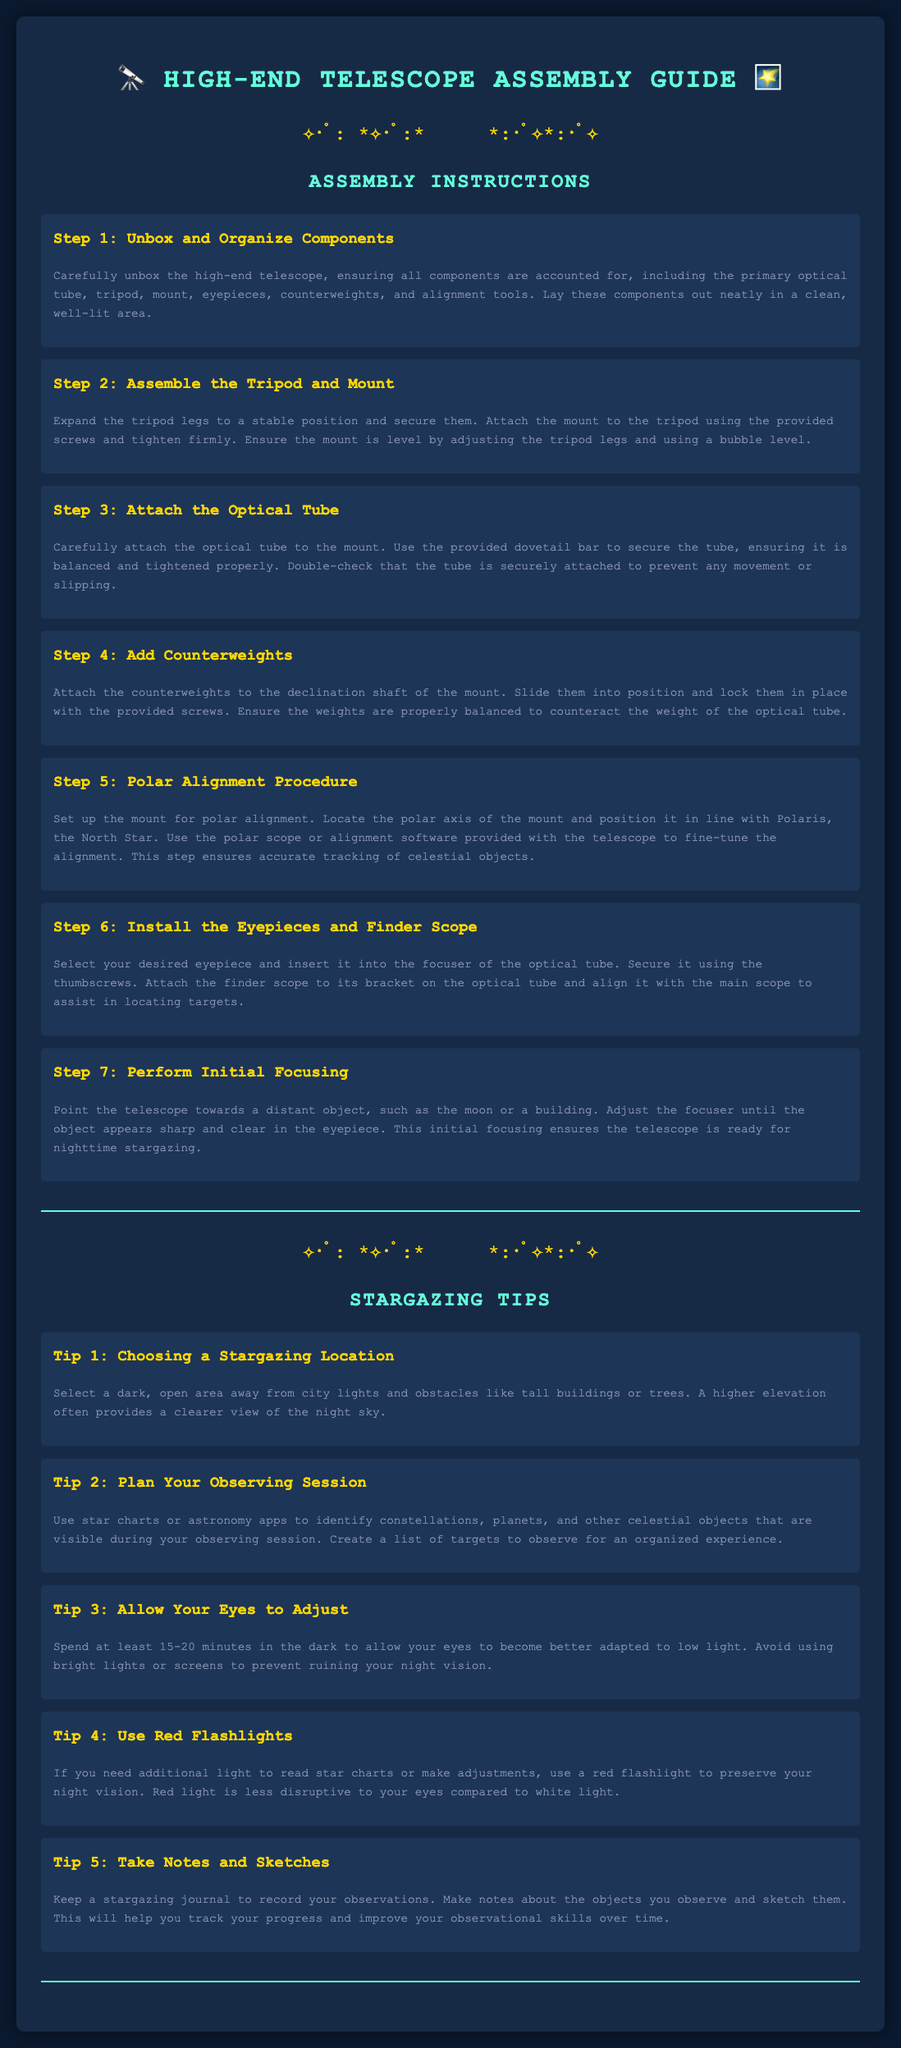What is the first step in assembling the telescope? The first step is to carefully unbox the high-end telescope, ensuring all components are accounted for.
Answer: Unbox and Organize Components How many eyepieces should be installed? The instructions specify selecting your desired eyepiece to insert into the focuser.
Answer: One What celestial object is used for the polar alignment? The document mentions aligning with Polaris, which is referred to as the North Star.
Answer: Polaris What color light is recommended for preserving night vision? The document suggests using red light to avoid disrupting night vision.
Answer: Red How long should you allow your eyes to adjust to the dark? It is recommended to spend at least 15-20 minutes in the dark to adjust your eyes.
Answer: 15-20 minutes What is the purpose of the counterweights in the assembly? Counterweights are used to balance the optical tube attached to the mount.
Answer: Balance What should you do before pointing the telescope at an object? Before pointing, you should perform initial focusing to ensure clarity.
Answer: Initial focusing What type of area is suggested for stargazing? The instructions recommend a dark, open area away from city lights.
Answer: Dark, open area 